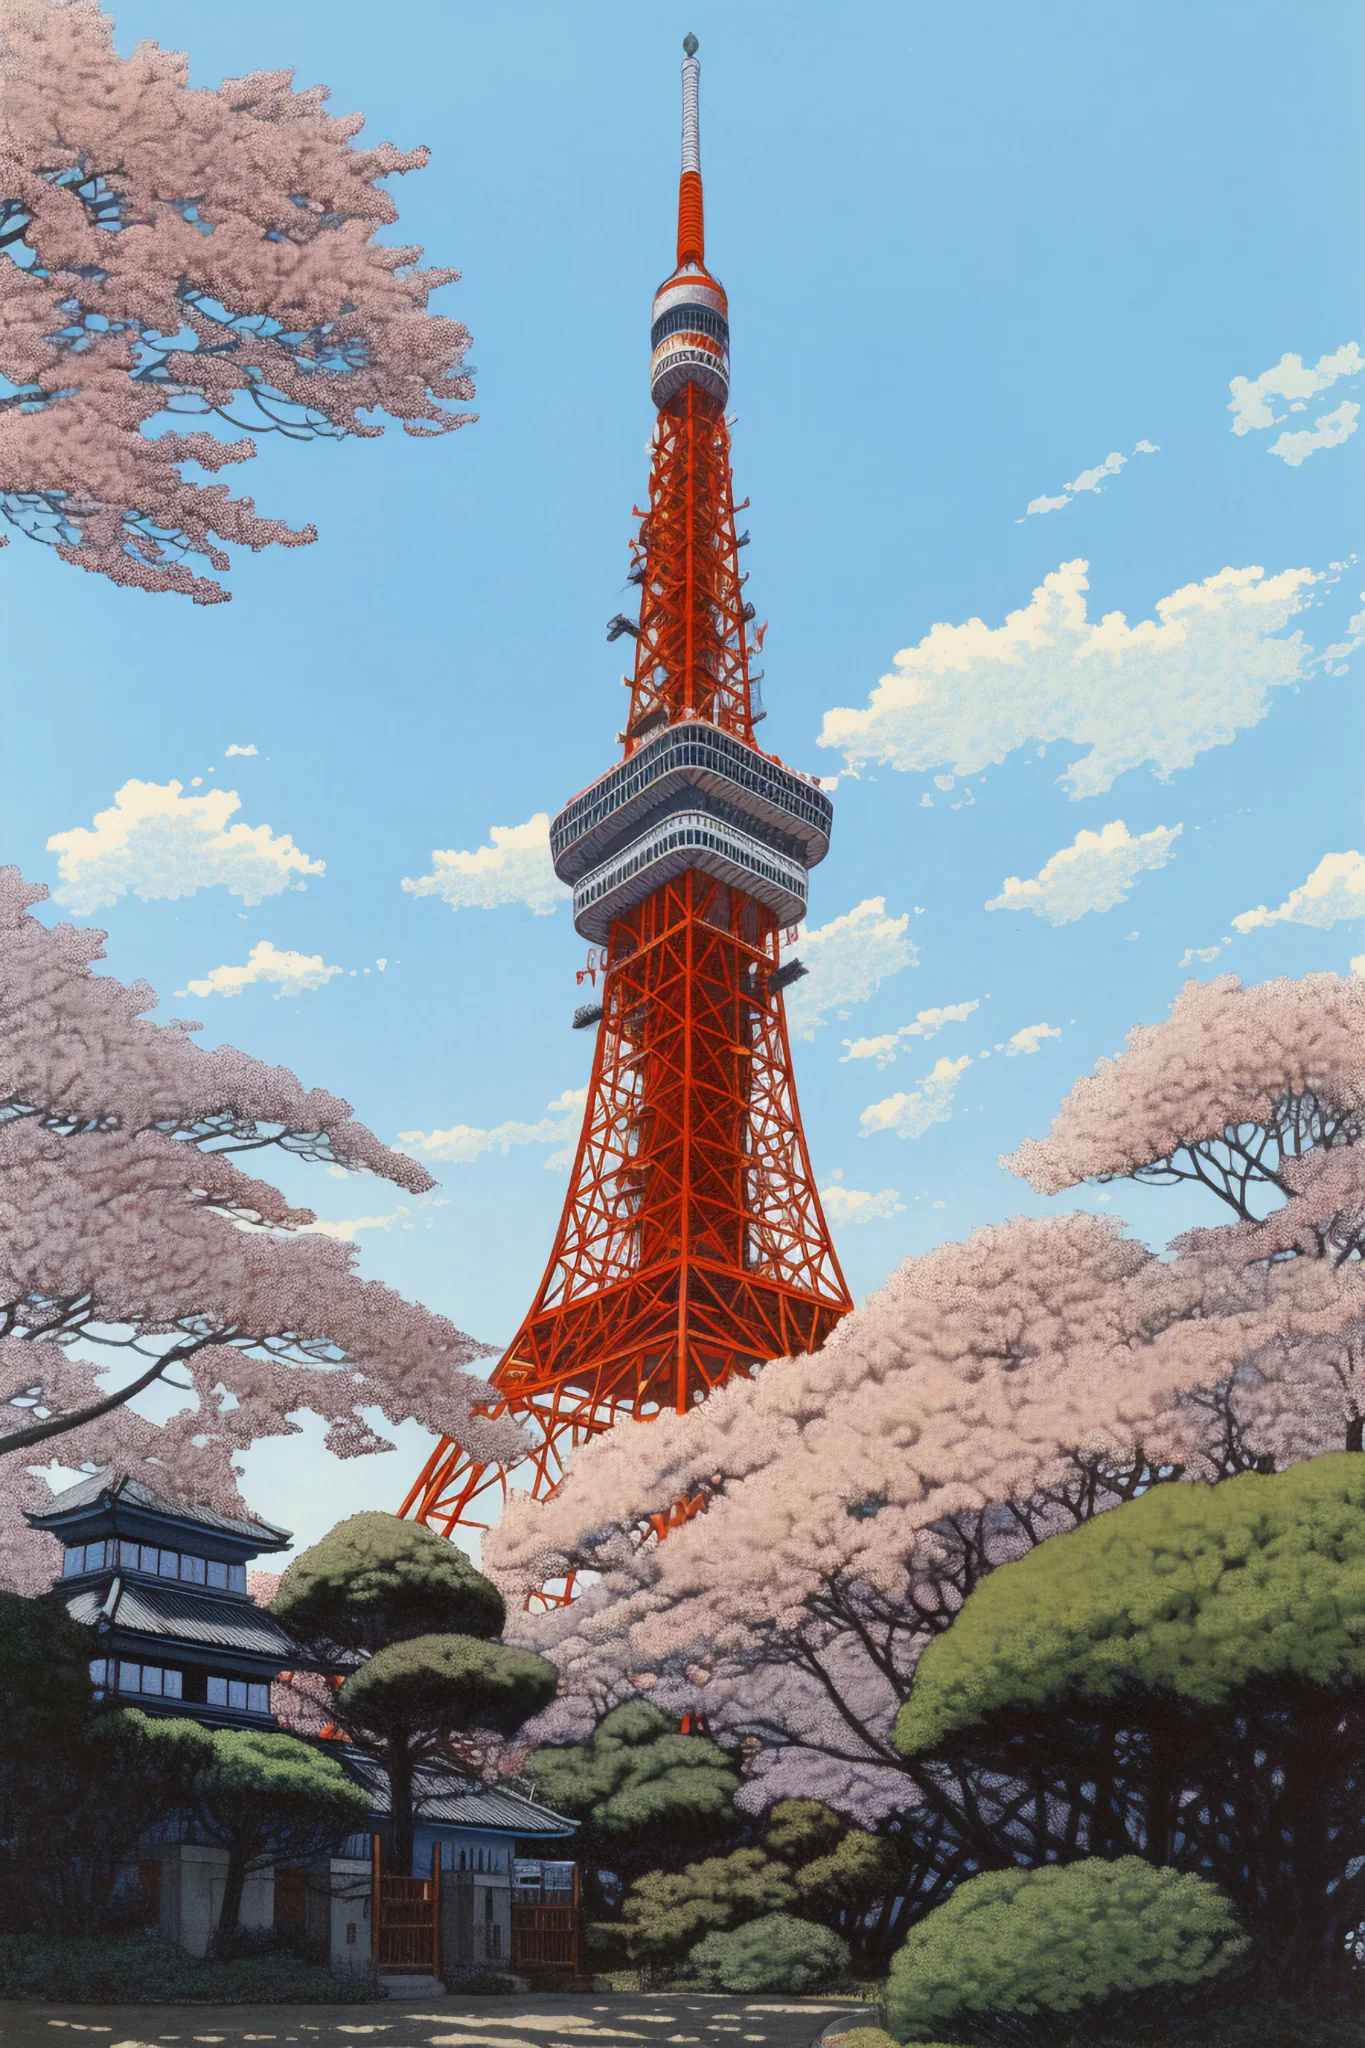Can you describe the environmental setting around Tokyo Tower shown in this picture? The environment around Tokyo Tower in this image shows a balance of meticulously maintained natural and built environments. Cherry trees in full blossom suggest the arrival of spring, a significant season in Japan known for outdoor viewings and celebrations of nature's fleeting beauty. The traditional Japanese building and well-groomed, evergreen trees underscore a respect for nature and history, typical of Japanese landscape design, which aims to create harmony between man-made structures and the natural world. 